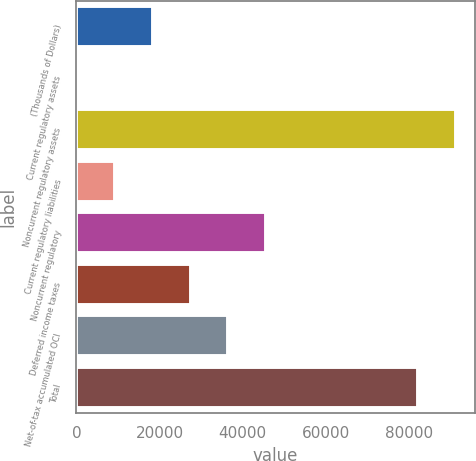Convert chart. <chart><loc_0><loc_0><loc_500><loc_500><bar_chart><fcel>(Thousands of Dollars)<fcel>Current regulatory assets<fcel>Noncurrent regulatory assets<fcel>Current regulatory liabilities<fcel>Noncurrent regulatory<fcel>Deferred income taxes<fcel>Net-of-tax accumulated OCI<fcel>Total<nl><fcel>18395.6<fcel>247<fcel>91226.3<fcel>9321.3<fcel>45618.5<fcel>27469.9<fcel>36544.2<fcel>82152<nl></chart> 